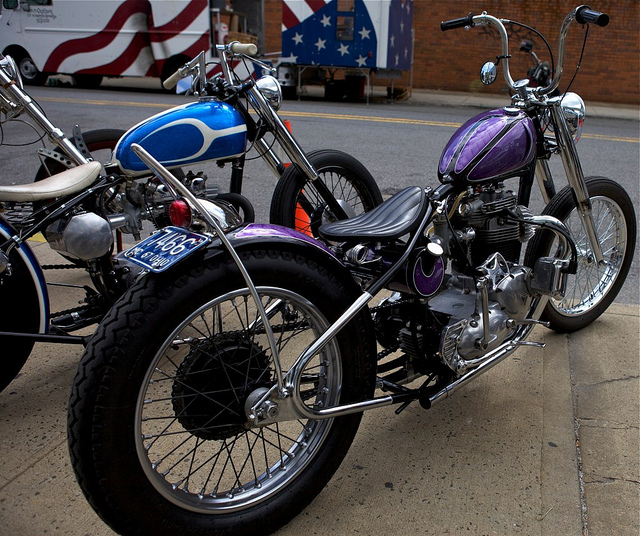Read all the text in this image. 7466 MC 67 